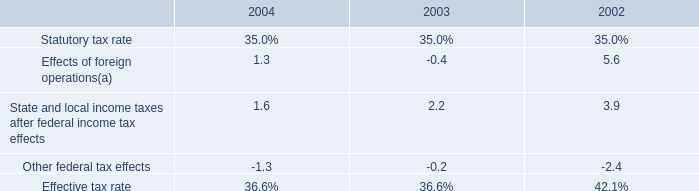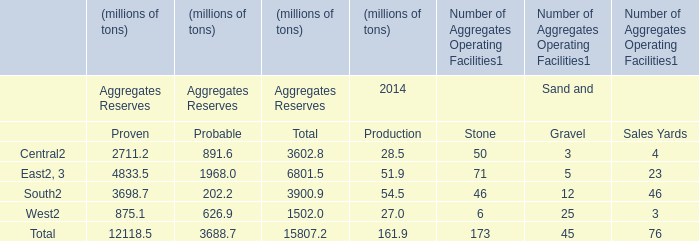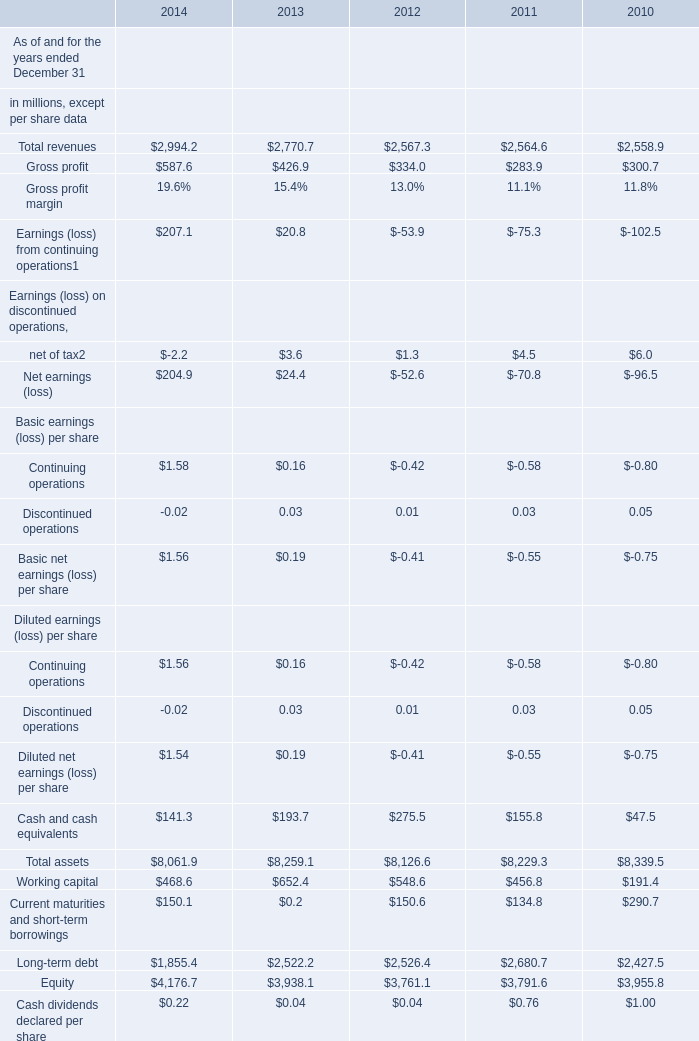If the value of Total assets develops with the same growth rate in 2012 ended December 31, what will it reach in 2013 ended December 31? (in million) 
Computations: (8126.6 * (1 + ((8126.6 - 8229.3) / 8229.3)))
Answer: 8025.18168. 